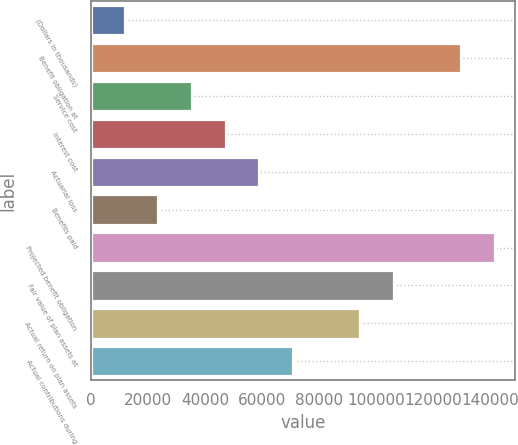Convert chart to OTSL. <chart><loc_0><loc_0><loc_500><loc_500><bar_chart><fcel>(Dollars in thousands)<fcel>Benefit obligation at<fcel>Service cost<fcel>Interest cost<fcel>Actuarial loss<fcel>Benefits paid<fcel>Projected benefit obligation<fcel>Fair value of plan assets at<fcel>Actual return on plan assets<fcel>Actual contributions during<nl><fcel>11893.1<fcel>129974<fcel>35509.3<fcel>47317.4<fcel>59125.5<fcel>23701.2<fcel>141782<fcel>106358<fcel>94549.8<fcel>70933.6<nl></chart> 